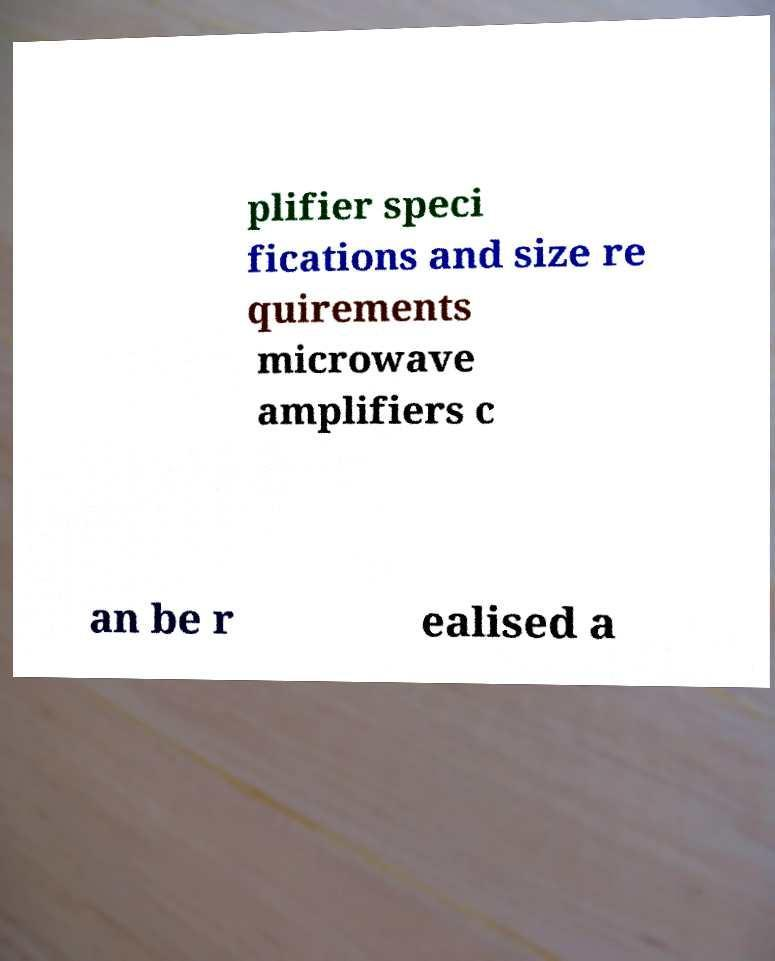I need the written content from this picture converted into text. Can you do that? plifier speci fications and size re quirements microwave amplifiers c an be r ealised a 